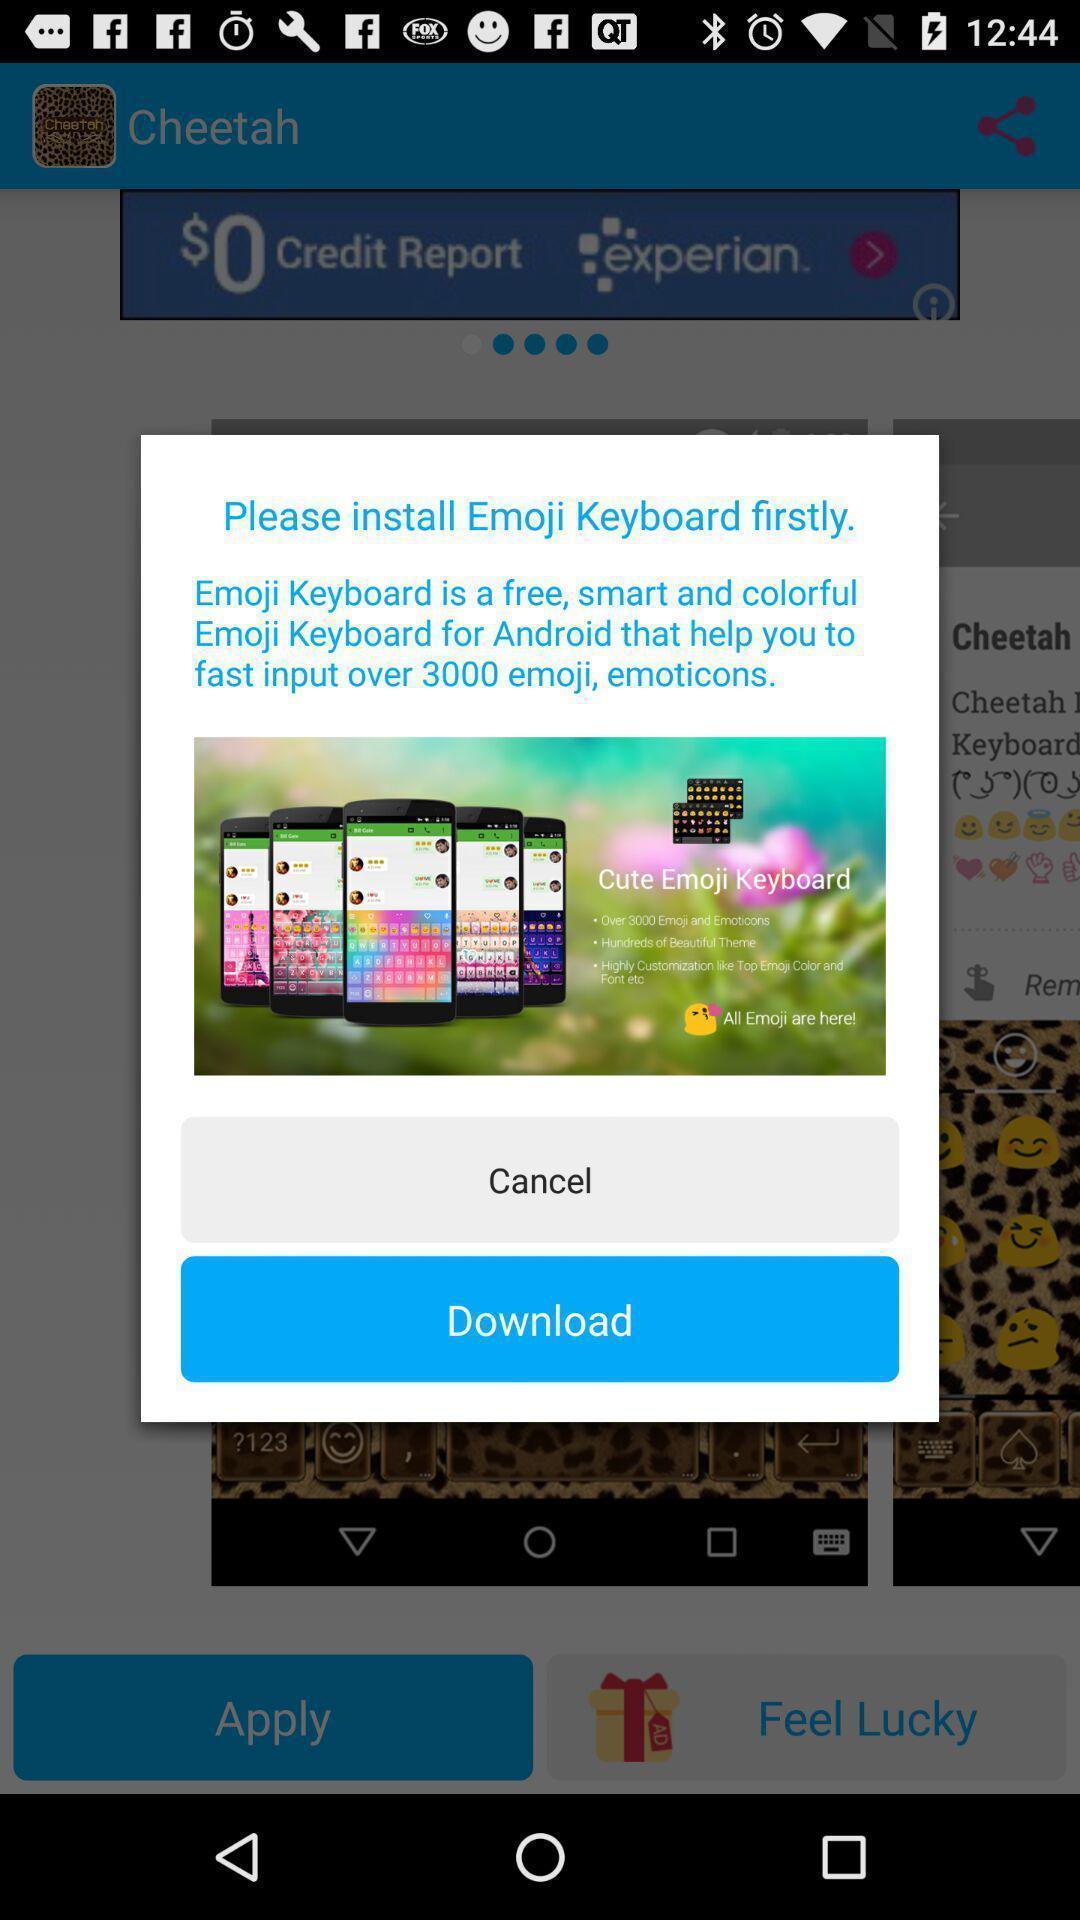Describe this image in words. Pop-up showing option like download. 